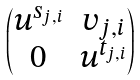Convert formula to latex. <formula><loc_0><loc_0><loc_500><loc_500>\begin{pmatrix} u ^ { s _ { j , i } } & v _ { j , i } \\ 0 & u ^ { t _ { j , i } } \end{pmatrix}</formula> 